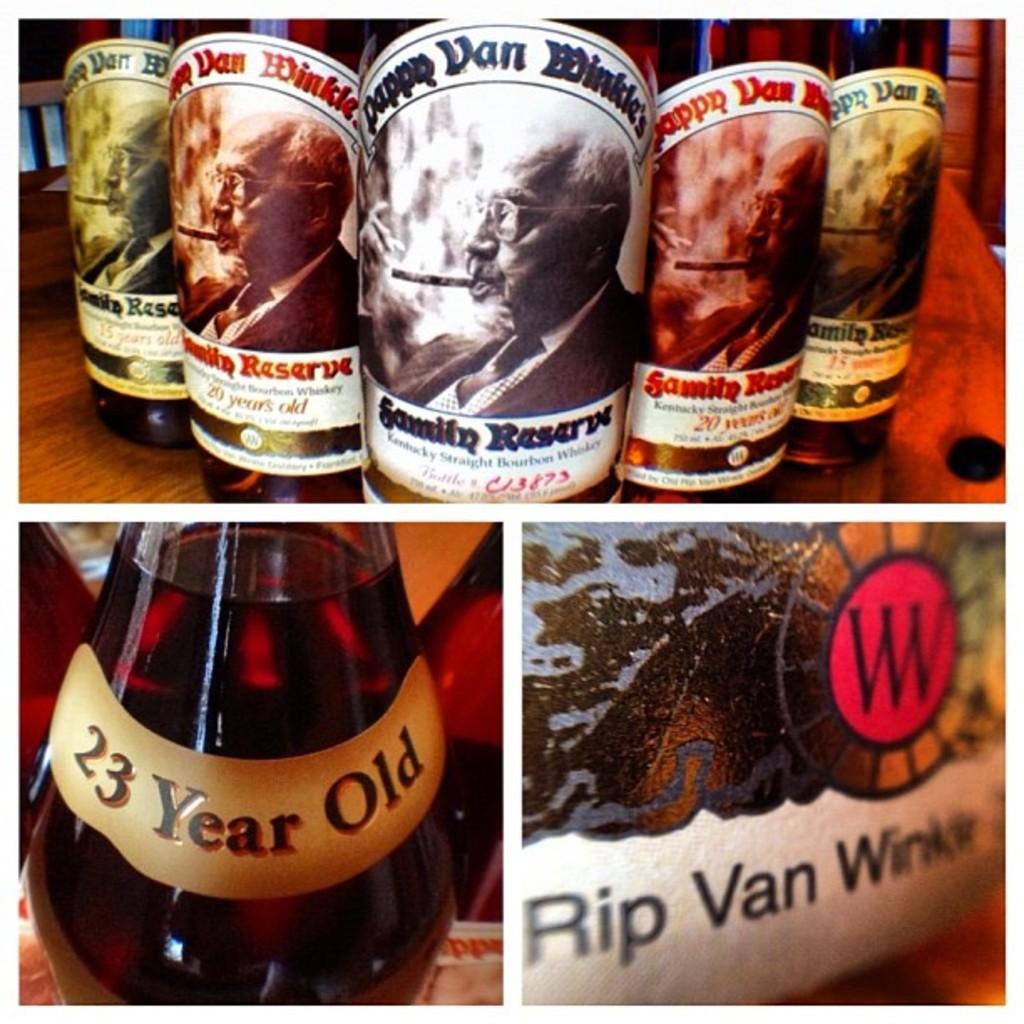Provide a one-sentence caption for the provided image. A selection of Pappy Van Winkle whiskey bottles. 